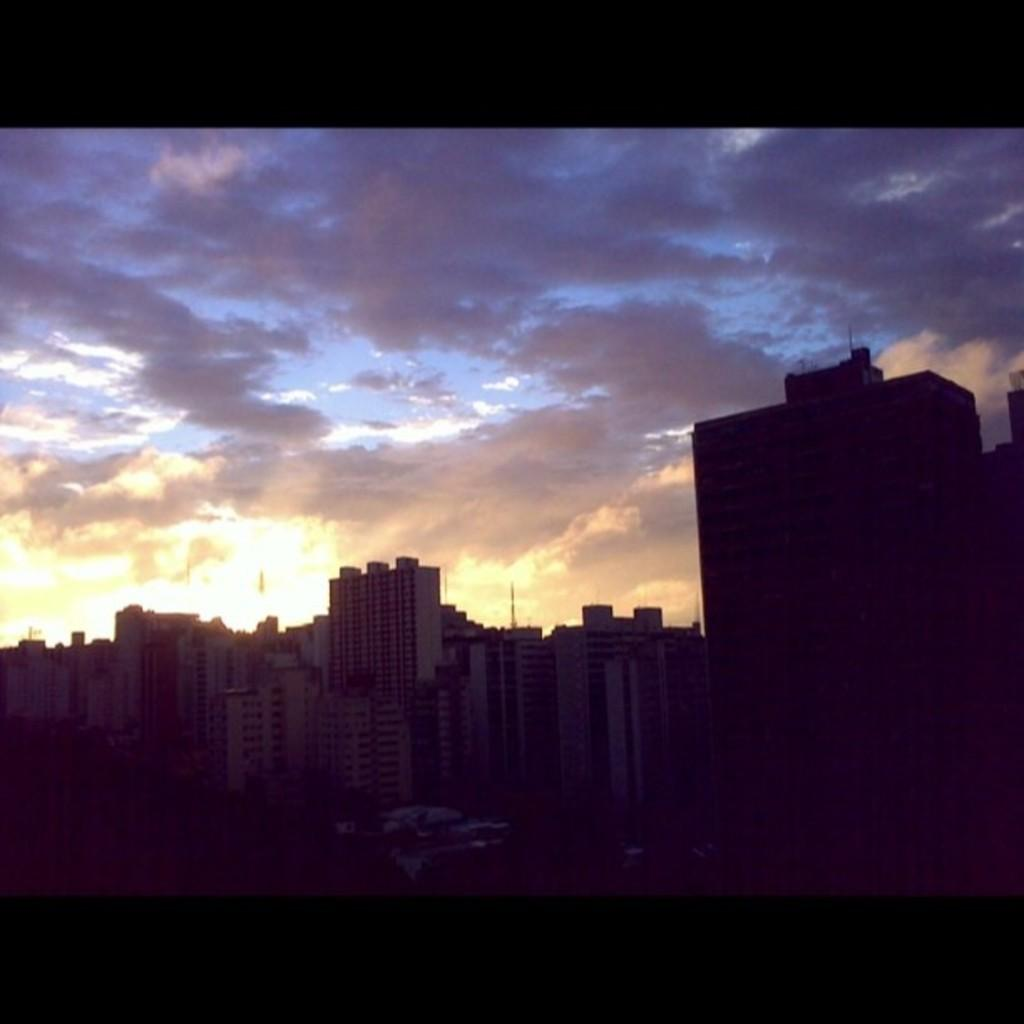What type of structures can be seen in the image? There are buildings in the image. What is visible in the background of the image? The sky is visible in the background of the image. What can be observed in the sky? Clouds are present in the sky. What type of calendar is hanging on the wall in the image? There is no calendar present in the image; it only features buildings and the sky. 